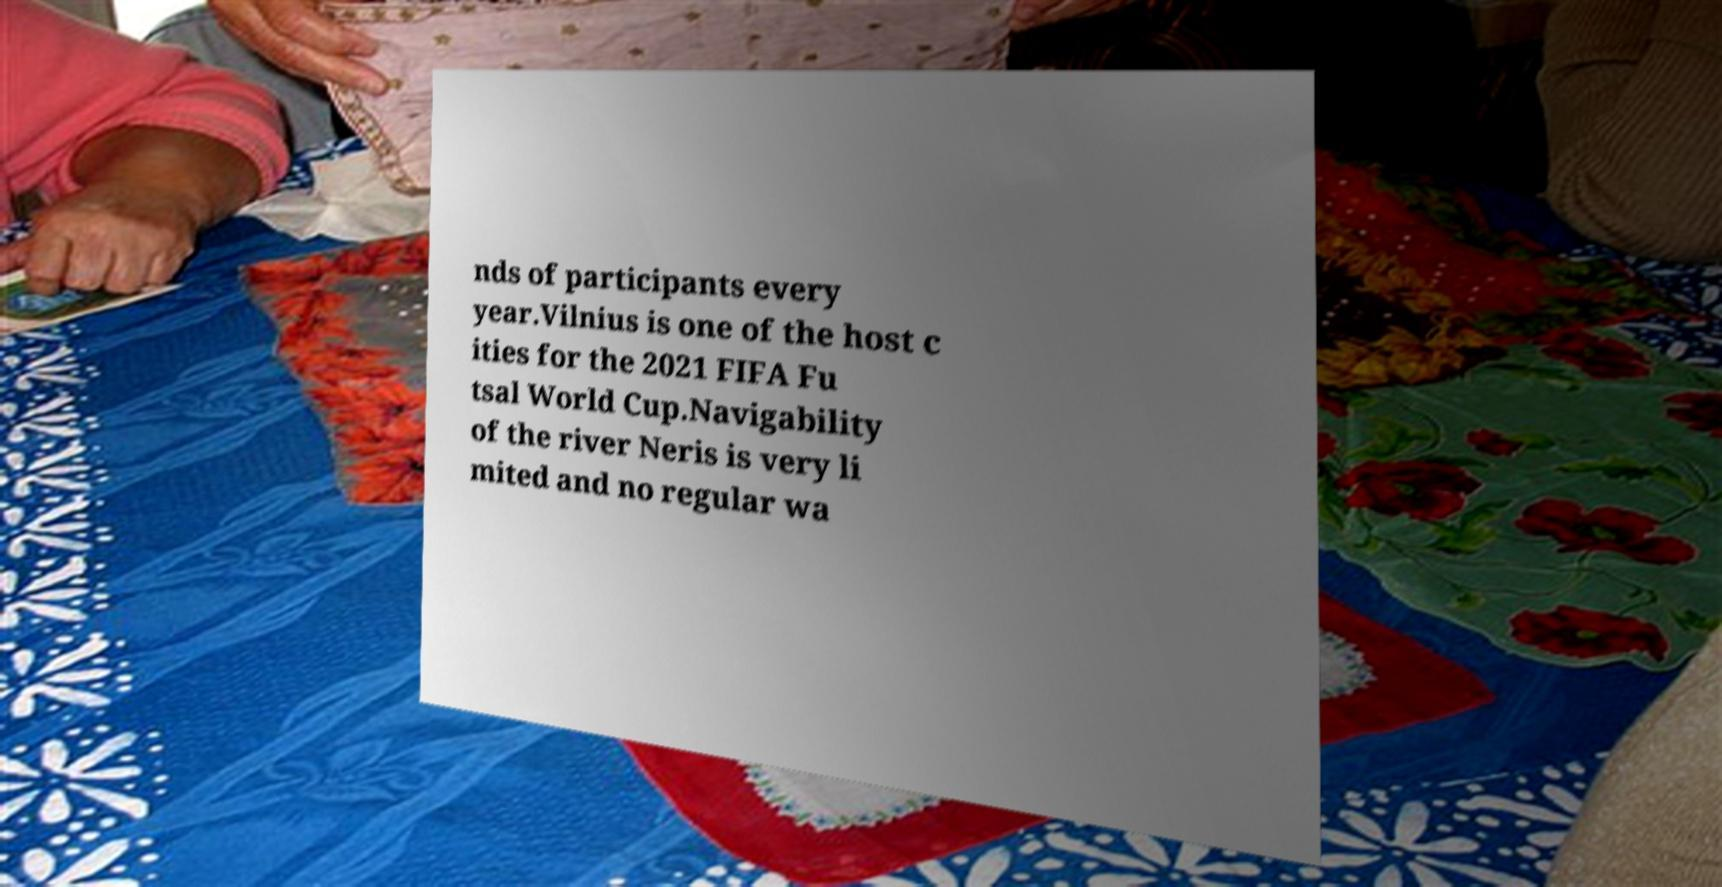Please identify and transcribe the text found in this image. nds of participants every year.Vilnius is one of the host c ities for the 2021 FIFA Fu tsal World Cup.Navigability of the river Neris is very li mited and no regular wa 